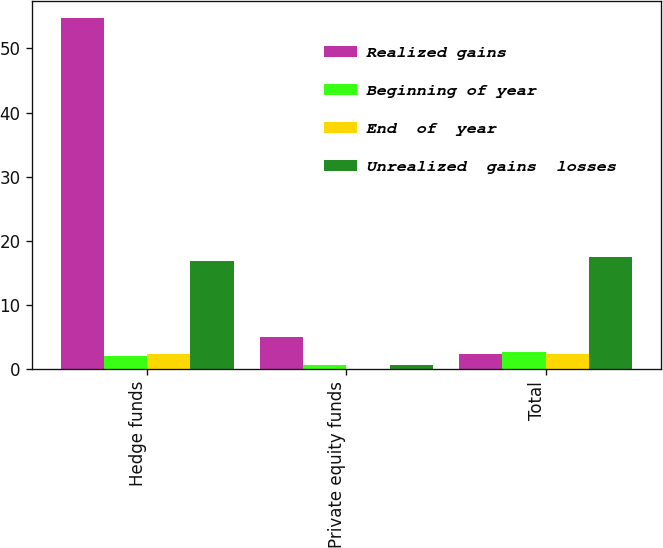Convert chart to OTSL. <chart><loc_0><loc_0><loc_500><loc_500><stacked_bar_chart><ecel><fcel>Hedge funds<fcel>Private equity funds<fcel>Total<nl><fcel>Realized gains<fcel>54.7<fcel>5<fcel>2.4<nl><fcel>Beginning of year<fcel>2<fcel>0.7<fcel>2.7<nl><fcel>End  of  year<fcel>2.3<fcel>0.1<fcel>2.4<nl><fcel>Unrealized  gains  losses<fcel>16.8<fcel>0.7<fcel>17.5<nl></chart> 